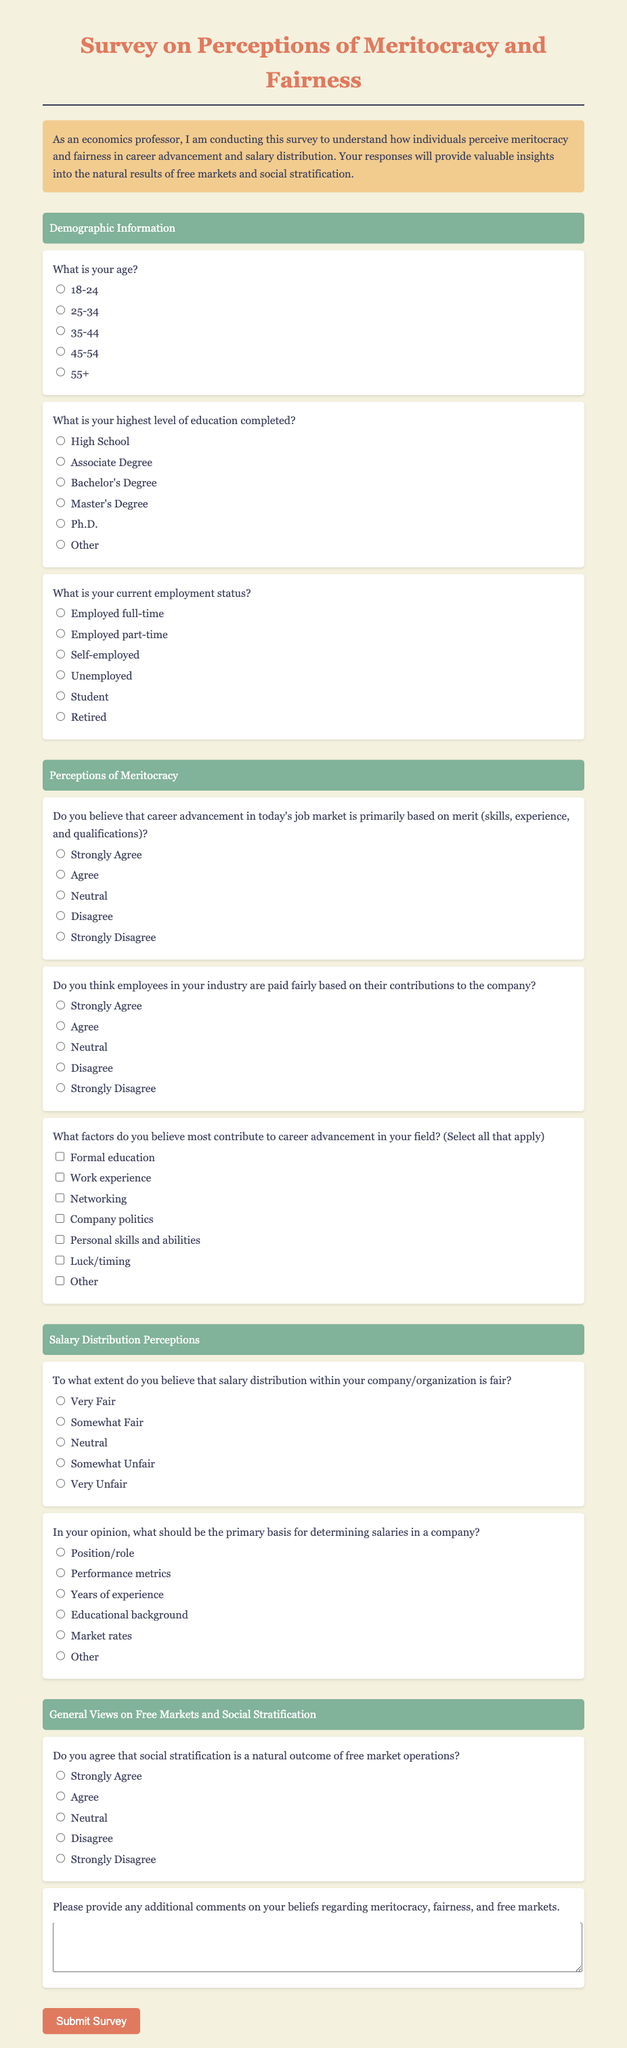What is the title of the survey? The title of the survey is prominently displayed at the top of the document.
Answer: Survey on Perceptions of Meritocracy and Fairness What is the color scheme primarily used in the document? The document has a soothing color scheme with predominantly light and earthy tones.
Answer: Light and earthy tones How many main sections does the survey have? The survey organizes content into several distinct sections with headers.
Answer: Three What options are available for the highest level of education completed? The survey lists various educational achievements as response options.
Answer: High School, Associate Degree, Bachelor's Degree, Master's Degree, Ph.D., Other What is one factor believed to contribute to career advancement according to the survey? The survey presents several factors that respondents can select regarding career advancement.
Answer: Networking To what extent can participants agree that salary distribution within their organization is fair? The question offers a scale for participants to assess salary fairness.
Answer: Very Fair, Somewhat Fair, Neutral, Somewhat Unfair, Very Unfair What is the purpose of the survey as stated in the description? The introductory description outlines the objective of the survey clearly.
Answer: To understand perceptions of meritocracy and fairness What type of employment status options are included in the document? The survey offers various statuses for respondents to choose from.
Answer: Employed full-time, Employed part-time, Self-employed, Unemployed, Student, Retired Do respondents have the option to provide additional comments? The survey asks for further thoughts from respondents on the topics covered.
Answer: Yes 